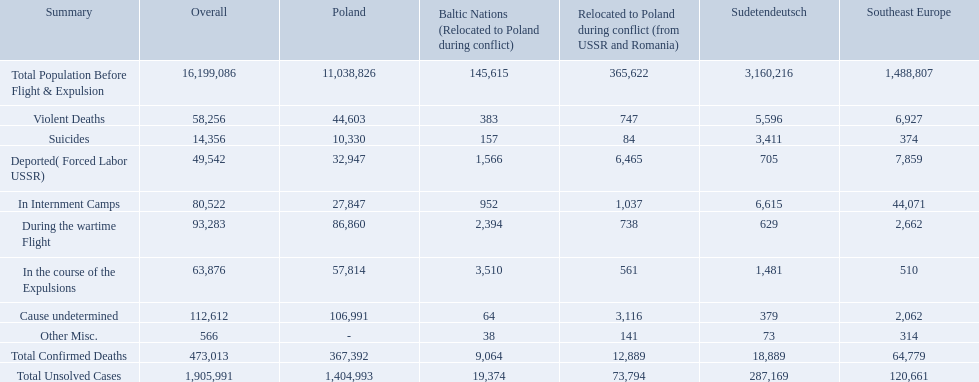What were the total number of confirmed deaths? 473,013. Of these, how many were violent? 58,256. How many total confirmed deaths were there in the baltic states? 9,064. How many deaths had an undetermined cause? 64. How many deaths in that region were miscellaneous? 38. Were there more deaths from an undetermined cause or that were listed as miscellaneous? Cause undetermined. 